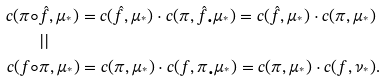Convert formula to latex. <formula><loc_0><loc_0><loc_500><loc_500>c ( \pi \circ & \hat { f } , \mu _ { ^ { * } } ) = c ( \hat { f } , \mu _ { ^ { * } } ) \cdot c ( \pi , \hat { f } _ { \bullet } \mu _ { ^ { * } } ) = c ( \hat { f } , \mu _ { ^ { * } } ) \cdot c ( \pi , \mu _ { ^ { * } } ) \\ & | | \\ c ( f \circ & \pi , \mu _ { ^ { * } } ) = c ( \pi , \mu _ { ^ { * } } ) \cdot c ( f , \pi _ { \bullet } \mu _ { ^ { * } } ) = c ( \pi , \mu _ { ^ { * } } ) \cdot c ( f , \nu _ { ^ { * } } ) .</formula> 